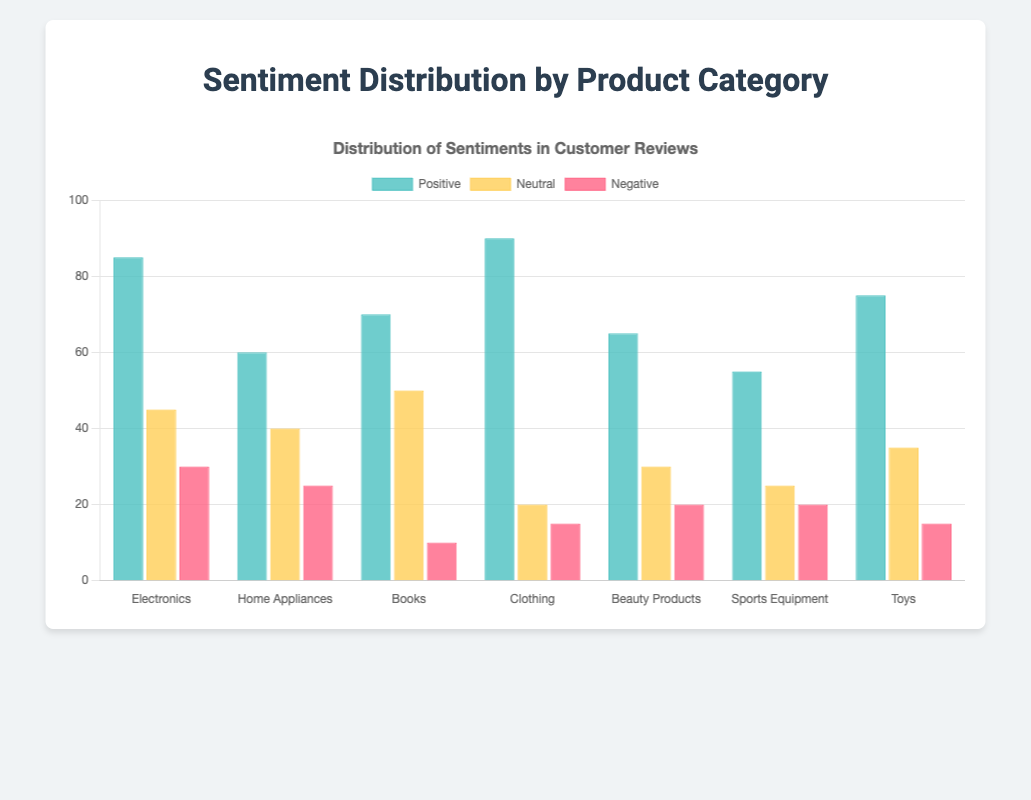What is the product category with the highest number of positive sentiments? Looking at the bars labeled "Positive," the Clothing category has the tallest bar, indicating the highest number of positive sentiments, which is 90.
Answer: Clothing Which product category has the lowest number of negative sentiments? The height of the "Negative" bars shows that the Books category has the lowest number of negative sentiments, which is 10.
Answer: Books What is the total number of neutral sentiments across all product categories? Summing the values of the neutral sentiments for each category: 45 (Electronics) + 40 (Home Appliances) + 50 (Books) + 20 (Clothing) + 30 (Beauty Products) + 25 (Sports Equipment) + 35 (Toys) = 245.
Answer: 245 Which product category has more negative sentiments than neutral sentiments? By comparing the heights of the "Negative" and "Neutral" bars for each category, no category has more negative sentiments than neutral sentiments.
Answer: None Between Electronics and Toys, which category has a higher sum of positive and negative sentiments? Summing the positive and negative sentiments for each:
- Electronics: 85 (Positive) + 30 (Negative) = 115
- Toys: 75 (Positive) + 15 (Negative) = 90
Electronics has a higher sum of positive and negative sentiments.
Answer: Electronics Among all categories, what is the average number of positive sentiments? Summing the positive sentiments and dividing by the number of categories: 
(85 + 60 + 70 + 90 + 65 + 55 + 75) / 7 = 71.43
Answer: 71.43 Which product category has the greatest difference between positive and negative sentiments? Calculating the difference for each category:
- Electronics: 85 - 30 = 55
- Home Appliances: 60 - 25 = 35
- Books: 70 - 10 = 60
- Clothing: 90 - 15 = 75
- Beauty Products: 65 - 20 = 45
- Sports Equipment: 55 - 20 = 35
- Toys: 75 - 15 = 60
Clothing has the greatest difference, which is 75.
Answer: Clothing Are there any categories where the number of neutral sentiments is equal to the number of positive sentiments? Comparing the heights of the "Neutral" and "Positive" bars, no category has equal numbers of neutral and positive sentiments.
Answer: No Which color represents the positive sentiments in the bar chart? The color for the positive sentiments bars is visually distinct as it is green.
Answer: Green 